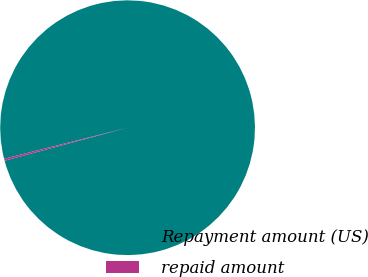Convert chart. <chart><loc_0><loc_0><loc_500><loc_500><pie_chart><fcel>Repayment amount (US)<fcel>repaid amount<nl><fcel>99.75%<fcel>0.25%<nl></chart> 